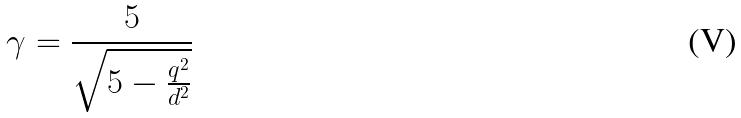Convert formula to latex. <formula><loc_0><loc_0><loc_500><loc_500>\gamma = \frac { 5 } { \sqrt { 5 - \frac { q ^ { 2 } } { d ^ { 2 } } } }</formula> 